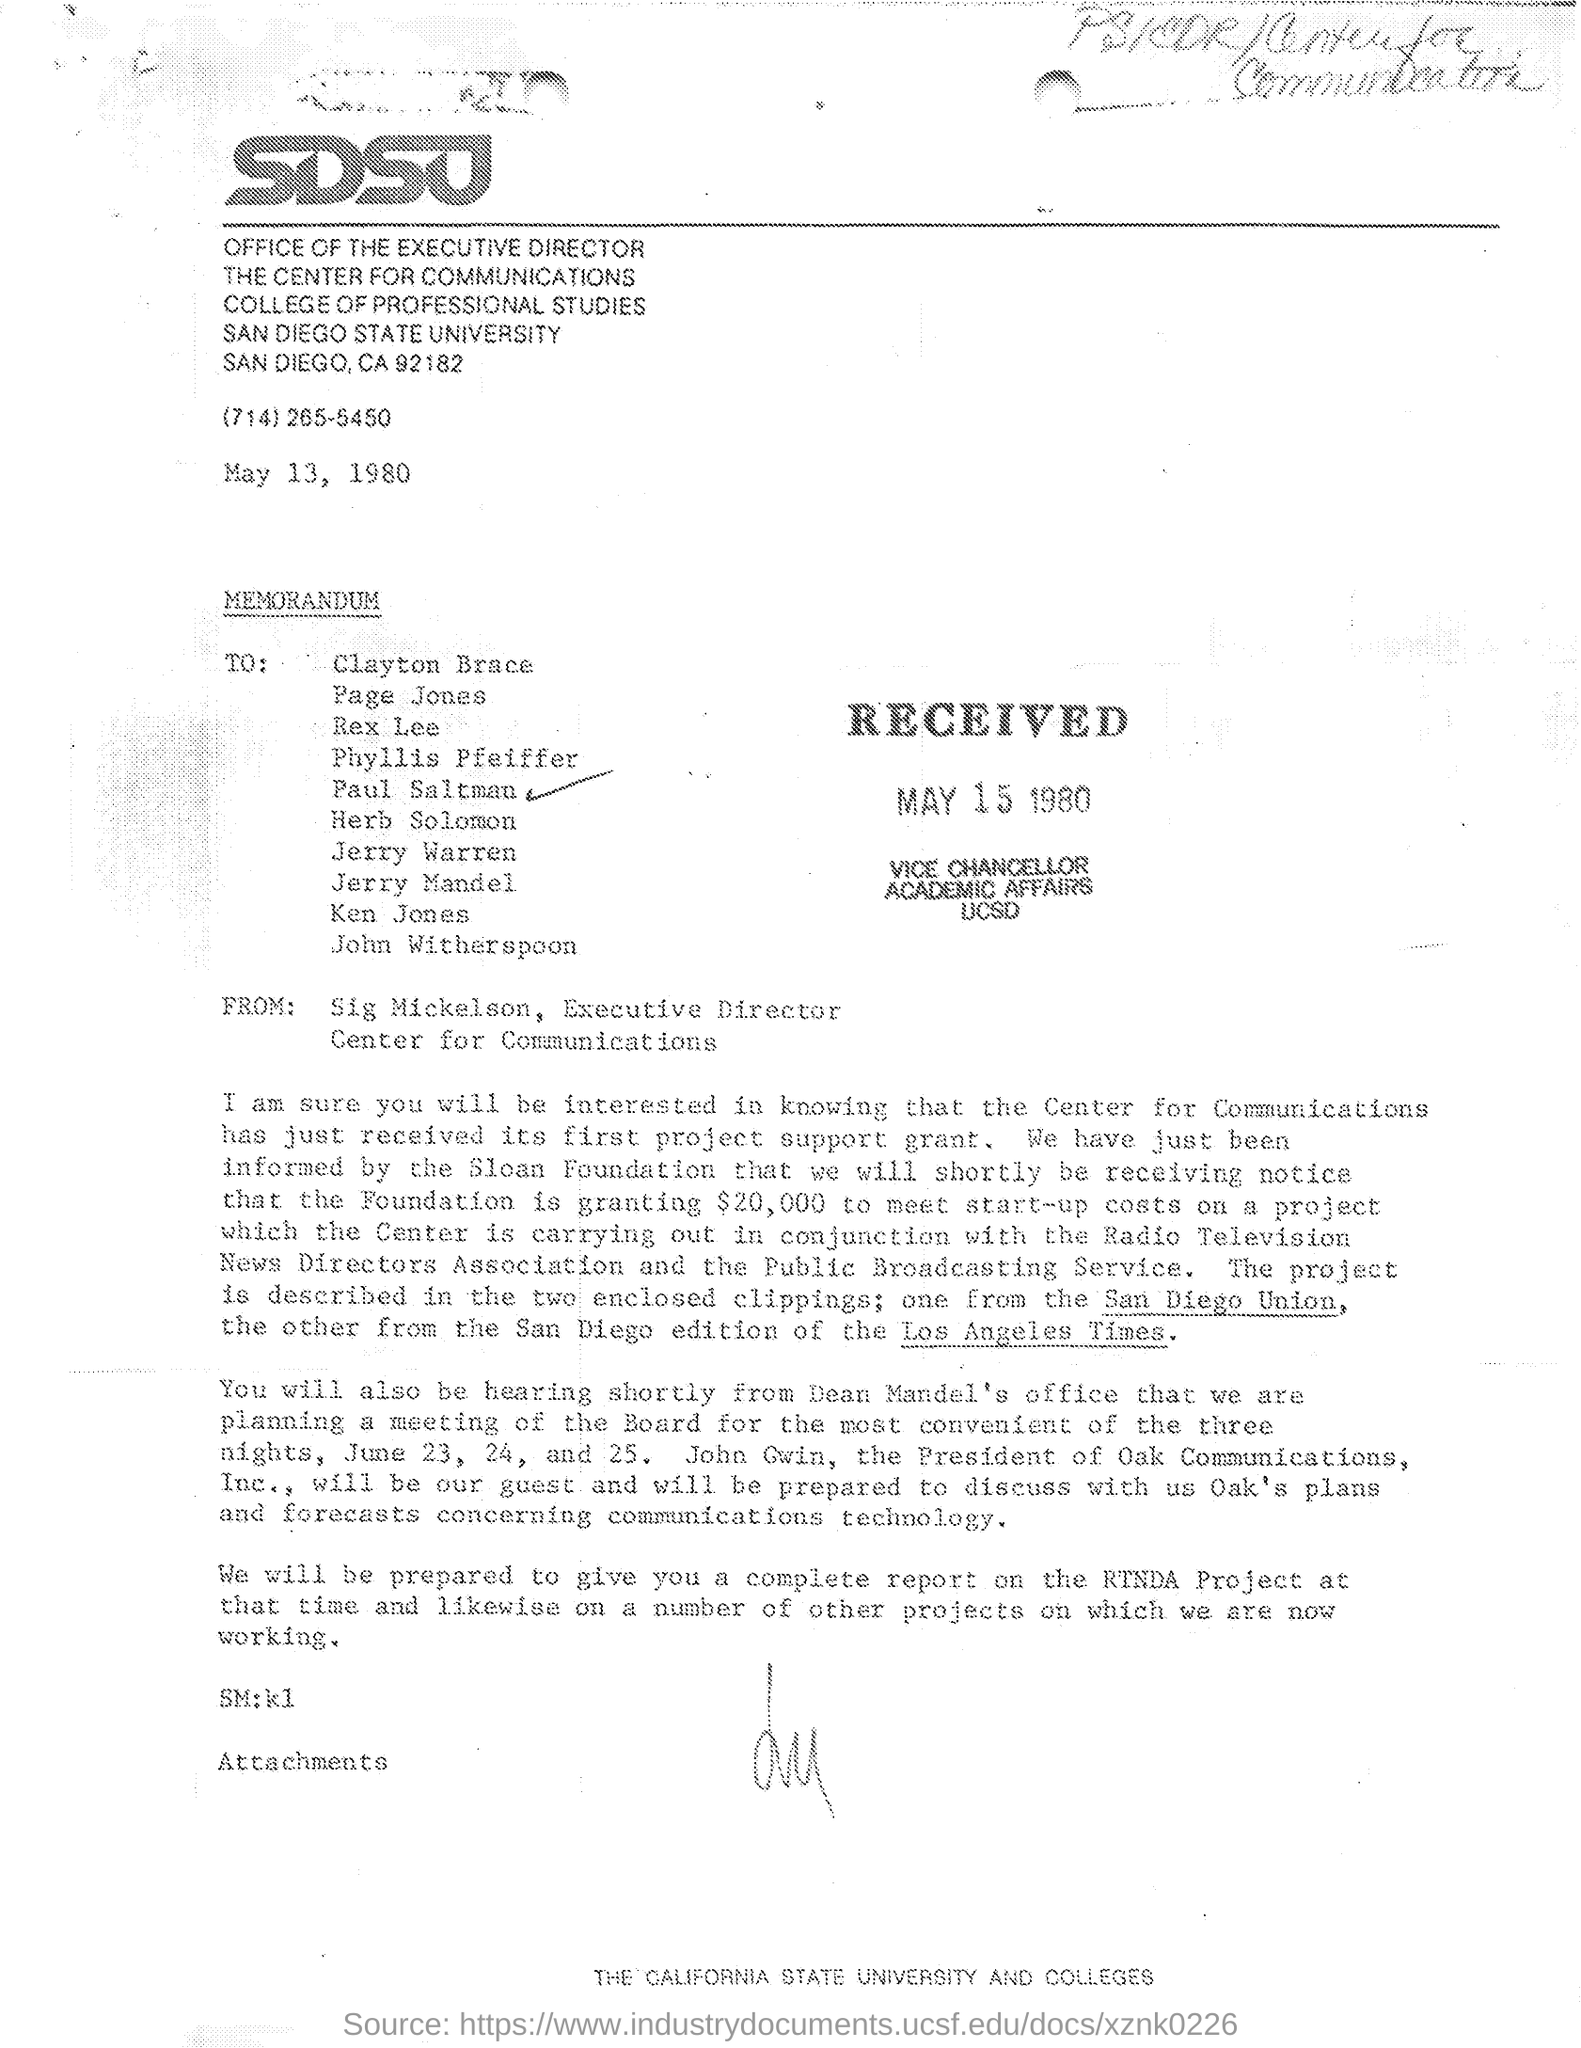Mention a couple of crucial points in this snapshot. The memorandum was sent by Sig Mickelson, the Executive Director. The received date of this memorandum is May 15, 1980. 